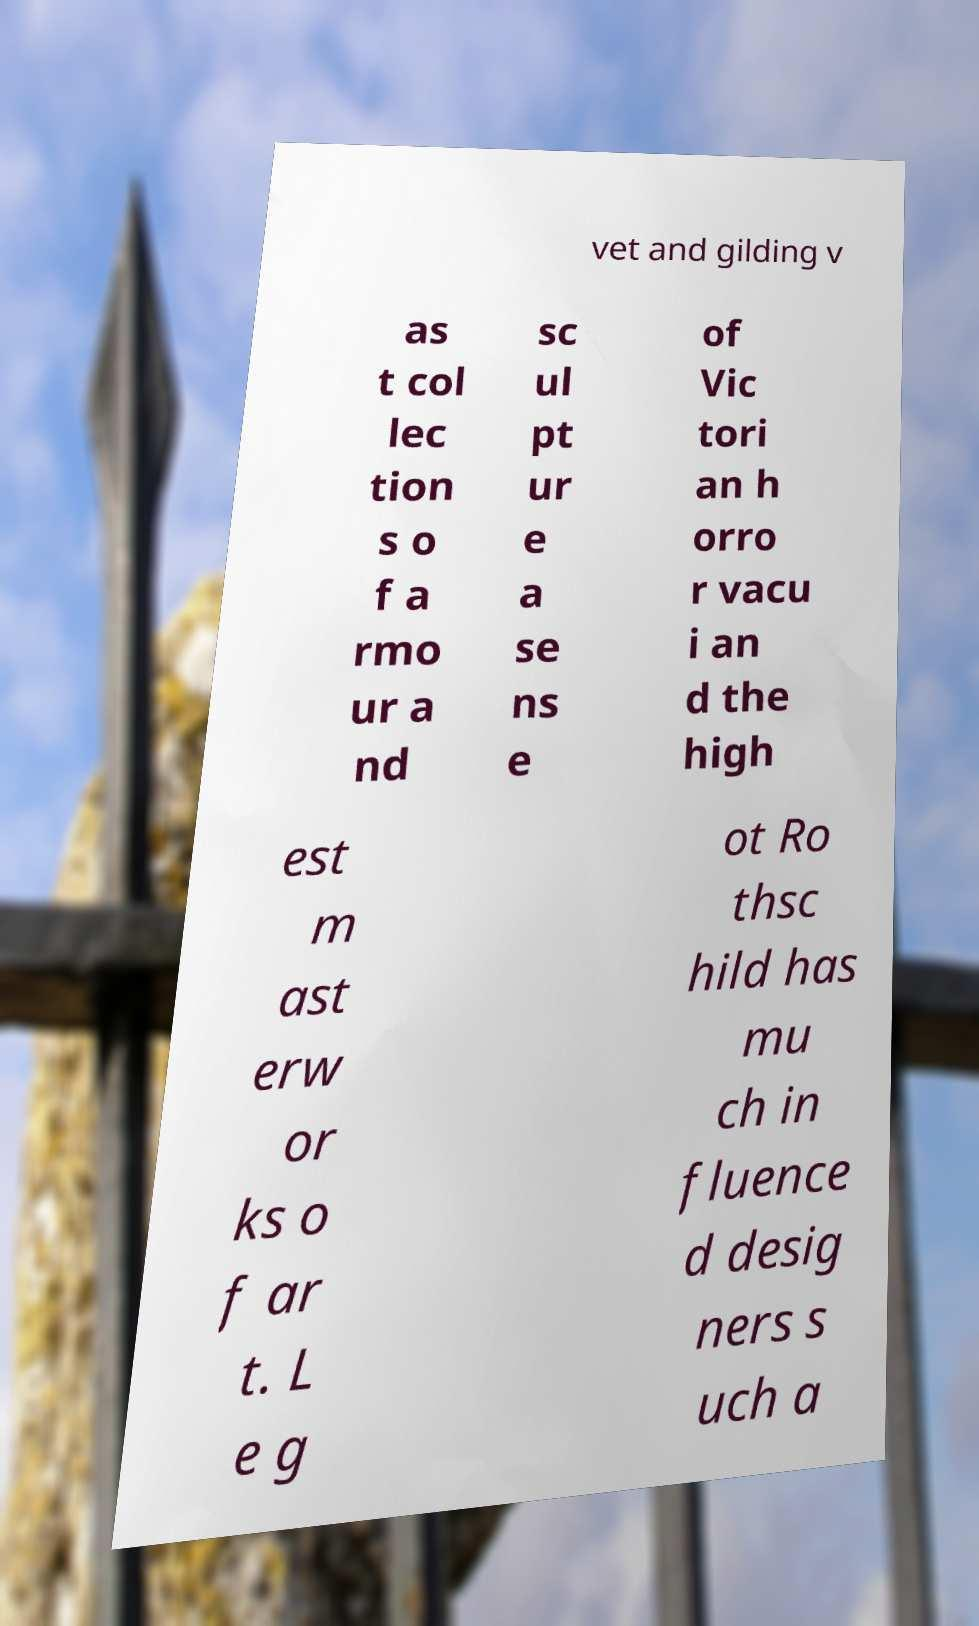There's text embedded in this image that I need extracted. Can you transcribe it verbatim? vet and gilding v as t col lec tion s o f a rmo ur a nd sc ul pt ur e a se ns e of Vic tori an h orro r vacu i an d the high est m ast erw or ks o f ar t. L e g ot Ro thsc hild has mu ch in fluence d desig ners s uch a 